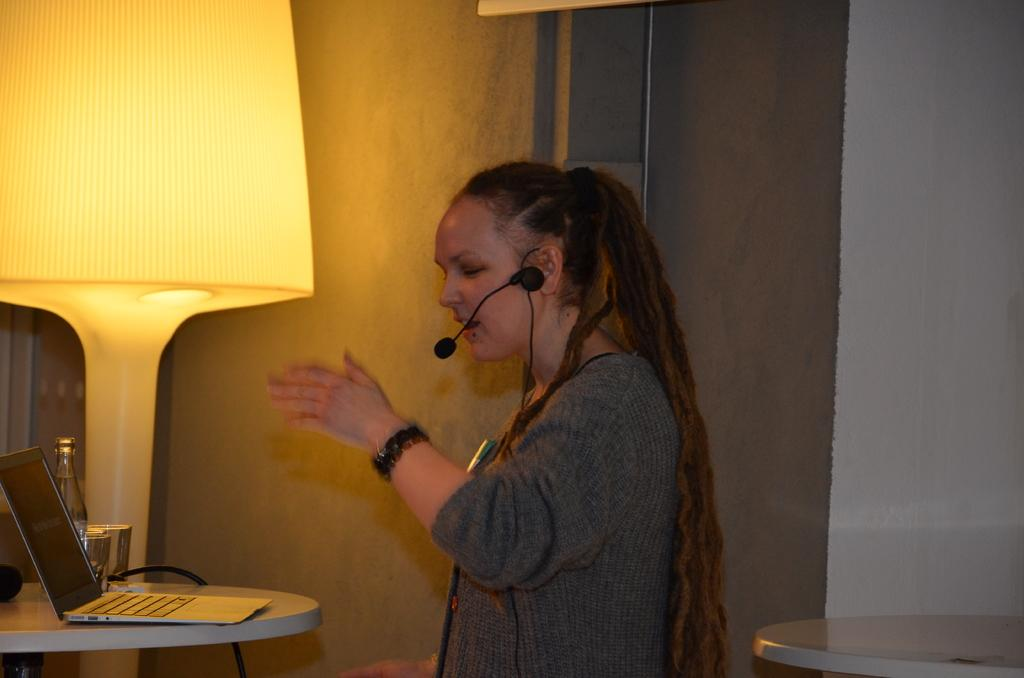Who is present in the image? There is a woman in the image. What object is visible in the woman's hand? There is a microphone in the image. What electronic device is present in the image? There is a laptop in the image. What beverage container is visible in the image? There is a bottle in the image. What type of tableware is present in the image? There are glasses in the image. What piece of furniture is present in the image? The table is present in the image. What can be seen in the background of the image? There is a wall, a lamp, and some objects in the background of the image. What type of dock is visible in the image? There is no dock present in the image. Can you confirm the existence of the woman's father in the image? The presence of the woman's father is not mentioned in the image, so it cannot be confirmed. 